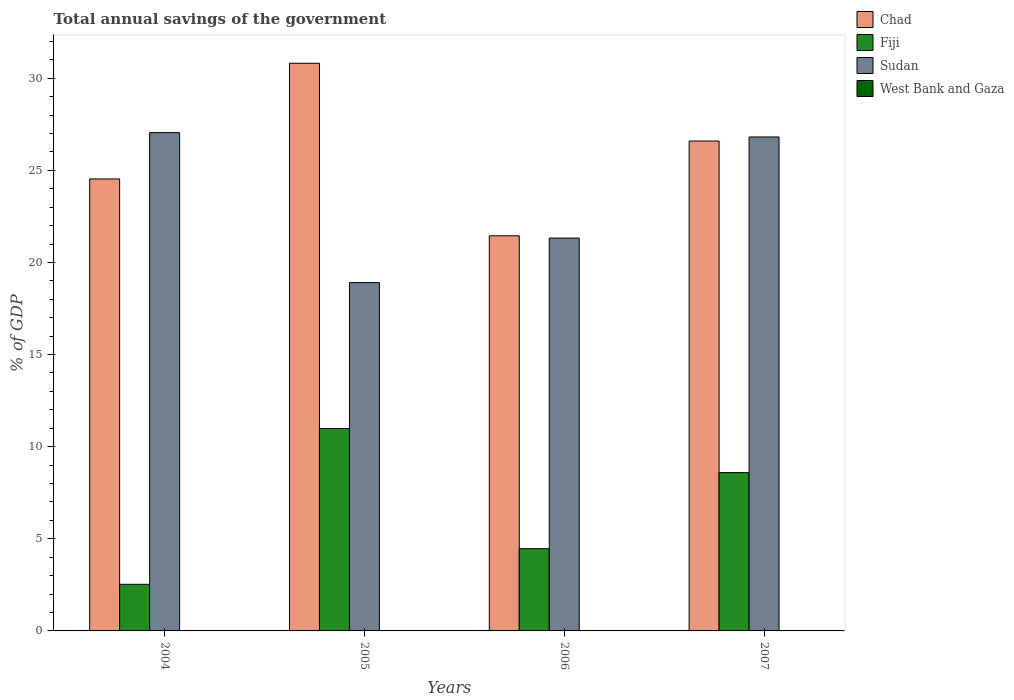How many different coloured bars are there?
Your answer should be very brief. 3. Are the number of bars per tick equal to the number of legend labels?
Your answer should be compact. No. Are the number of bars on each tick of the X-axis equal?
Offer a terse response. Yes. How many bars are there on the 1st tick from the left?
Your answer should be very brief. 3. How many bars are there on the 4th tick from the right?
Provide a short and direct response. 3. What is the total annual savings of the government in Fiji in 2006?
Provide a succinct answer. 4.47. Across all years, what is the maximum total annual savings of the government in Fiji?
Offer a very short reply. 10.99. What is the total total annual savings of the government in Fiji in the graph?
Provide a short and direct response. 26.58. What is the difference between the total annual savings of the government in Chad in 2004 and that in 2007?
Your response must be concise. -2.06. What is the difference between the total annual savings of the government in Fiji in 2007 and the total annual savings of the government in Chad in 2005?
Your answer should be very brief. -22.22. What is the average total annual savings of the government in Chad per year?
Provide a short and direct response. 25.85. In the year 2004, what is the difference between the total annual savings of the government in Fiji and total annual savings of the government in Chad?
Offer a very short reply. -22. In how many years, is the total annual savings of the government in Fiji greater than 20 %?
Offer a terse response. 0. What is the ratio of the total annual savings of the government in Sudan in 2004 to that in 2006?
Give a very brief answer. 1.27. What is the difference between the highest and the second highest total annual savings of the government in Sudan?
Give a very brief answer. 0.23. What is the difference between the highest and the lowest total annual savings of the government in Chad?
Keep it short and to the point. 9.36. Is the sum of the total annual savings of the government in Sudan in 2006 and 2007 greater than the maximum total annual savings of the government in Chad across all years?
Make the answer very short. Yes. Is it the case that in every year, the sum of the total annual savings of the government in Chad and total annual savings of the government in Sudan is greater than the sum of total annual savings of the government in West Bank and Gaza and total annual savings of the government in Fiji?
Offer a very short reply. No. Are the values on the major ticks of Y-axis written in scientific E-notation?
Provide a short and direct response. No. Does the graph contain any zero values?
Your response must be concise. Yes. Does the graph contain grids?
Keep it short and to the point. No. Where does the legend appear in the graph?
Make the answer very short. Top right. How many legend labels are there?
Offer a very short reply. 4. How are the legend labels stacked?
Provide a short and direct response. Vertical. What is the title of the graph?
Your response must be concise. Total annual savings of the government. Does "Jordan" appear as one of the legend labels in the graph?
Offer a terse response. No. What is the label or title of the Y-axis?
Provide a short and direct response. % of GDP. What is the % of GDP of Chad in 2004?
Offer a very short reply. 24.53. What is the % of GDP in Fiji in 2004?
Ensure brevity in your answer.  2.53. What is the % of GDP of Sudan in 2004?
Your answer should be very brief. 27.05. What is the % of GDP in West Bank and Gaza in 2004?
Ensure brevity in your answer.  0. What is the % of GDP in Chad in 2005?
Give a very brief answer. 30.81. What is the % of GDP of Fiji in 2005?
Provide a short and direct response. 10.99. What is the % of GDP of Sudan in 2005?
Your answer should be very brief. 18.9. What is the % of GDP in West Bank and Gaza in 2005?
Ensure brevity in your answer.  0. What is the % of GDP in Chad in 2006?
Provide a succinct answer. 21.45. What is the % of GDP of Fiji in 2006?
Provide a short and direct response. 4.47. What is the % of GDP in Sudan in 2006?
Ensure brevity in your answer.  21.32. What is the % of GDP of West Bank and Gaza in 2006?
Keep it short and to the point. 0. What is the % of GDP of Chad in 2007?
Make the answer very short. 26.59. What is the % of GDP of Fiji in 2007?
Your response must be concise. 8.59. What is the % of GDP in Sudan in 2007?
Give a very brief answer. 26.81. What is the % of GDP in West Bank and Gaza in 2007?
Give a very brief answer. 0. Across all years, what is the maximum % of GDP of Chad?
Offer a terse response. 30.81. Across all years, what is the maximum % of GDP of Fiji?
Ensure brevity in your answer.  10.99. Across all years, what is the maximum % of GDP in Sudan?
Give a very brief answer. 27.05. Across all years, what is the minimum % of GDP in Chad?
Offer a terse response. 21.45. Across all years, what is the minimum % of GDP in Fiji?
Provide a short and direct response. 2.53. Across all years, what is the minimum % of GDP in Sudan?
Your answer should be very brief. 18.9. What is the total % of GDP of Chad in the graph?
Offer a terse response. 103.38. What is the total % of GDP in Fiji in the graph?
Offer a terse response. 26.58. What is the total % of GDP of Sudan in the graph?
Provide a short and direct response. 94.09. What is the difference between the % of GDP of Chad in 2004 and that in 2005?
Make the answer very short. -6.28. What is the difference between the % of GDP in Fiji in 2004 and that in 2005?
Offer a very short reply. -8.46. What is the difference between the % of GDP of Sudan in 2004 and that in 2005?
Provide a short and direct response. 8.14. What is the difference between the % of GDP of Chad in 2004 and that in 2006?
Provide a short and direct response. 3.08. What is the difference between the % of GDP of Fiji in 2004 and that in 2006?
Make the answer very short. -1.94. What is the difference between the % of GDP in Sudan in 2004 and that in 2006?
Keep it short and to the point. 5.72. What is the difference between the % of GDP of Chad in 2004 and that in 2007?
Ensure brevity in your answer.  -2.06. What is the difference between the % of GDP in Fiji in 2004 and that in 2007?
Provide a short and direct response. -6.06. What is the difference between the % of GDP of Sudan in 2004 and that in 2007?
Provide a succinct answer. 0.23. What is the difference between the % of GDP in Chad in 2005 and that in 2006?
Provide a short and direct response. 9.36. What is the difference between the % of GDP of Fiji in 2005 and that in 2006?
Provide a short and direct response. 6.52. What is the difference between the % of GDP of Sudan in 2005 and that in 2006?
Keep it short and to the point. -2.42. What is the difference between the % of GDP in Chad in 2005 and that in 2007?
Provide a succinct answer. 4.22. What is the difference between the % of GDP in Fiji in 2005 and that in 2007?
Ensure brevity in your answer.  2.4. What is the difference between the % of GDP in Sudan in 2005 and that in 2007?
Your answer should be compact. -7.91. What is the difference between the % of GDP in Chad in 2006 and that in 2007?
Keep it short and to the point. -5.14. What is the difference between the % of GDP of Fiji in 2006 and that in 2007?
Offer a very short reply. -4.13. What is the difference between the % of GDP in Sudan in 2006 and that in 2007?
Ensure brevity in your answer.  -5.49. What is the difference between the % of GDP in Chad in 2004 and the % of GDP in Fiji in 2005?
Ensure brevity in your answer.  13.54. What is the difference between the % of GDP of Chad in 2004 and the % of GDP of Sudan in 2005?
Make the answer very short. 5.63. What is the difference between the % of GDP of Fiji in 2004 and the % of GDP of Sudan in 2005?
Provide a short and direct response. -16.37. What is the difference between the % of GDP of Chad in 2004 and the % of GDP of Fiji in 2006?
Keep it short and to the point. 20.07. What is the difference between the % of GDP in Chad in 2004 and the % of GDP in Sudan in 2006?
Ensure brevity in your answer.  3.21. What is the difference between the % of GDP in Fiji in 2004 and the % of GDP in Sudan in 2006?
Offer a terse response. -18.79. What is the difference between the % of GDP in Chad in 2004 and the % of GDP in Fiji in 2007?
Offer a very short reply. 15.94. What is the difference between the % of GDP of Chad in 2004 and the % of GDP of Sudan in 2007?
Provide a succinct answer. -2.28. What is the difference between the % of GDP of Fiji in 2004 and the % of GDP of Sudan in 2007?
Offer a very short reply. -24.28. What is the difference between the % of GDP of Chad in 2005 and the % of GDP of Fiji in 2006?
Keep it short and to the point. 26.35. What is the difference between the % of GDP of Chad in 2005 and the % of GDP of Sudan in 2006?
Provide a succinct answer. 9.49. What is the difference between the % of GDP of Fiji in 2005 and the % of GDP of Sudan in 2006?
Your answer should be compact. -10.34. What is the difference between the % of GDP in Chad in 2005 and the % of GDP in Fiji in 2007?
Your answer should be compact. 22.22. What is the difference between the % of GDP of Chad in 2005 and the % of GDP of Sudan in 2007?
Ensure brevity in your answer.  4. What is the difference between the % of GDP of Fiji in 2005 and the % of GDP of Sudan in 2007?
Provide a short and direct response. -15.82. What is the difference between the % of GDP of Chad in 2006 and the % of GDP of Fiji in 2007?
Your answer should be very brief. 12.86. What is the difference between the % of GDP of Chad in 2006 and the % of GDP of Sudan in 2007?
Offer a terse response. -5.36. What is the difference between the % of GDP in Fiji in 2006 and the % of GDP in Sudan in 2007?
Offer a terse response. -22.35. What is the average % of GDP of Chad per year?
Your answer should be very brief. 25.85. What is the average % of GDP in Fiji per year?
Provide a short and direct response. 6.64. What is the average % of GDP in Sudan per year?
Keep it short and to the point. 23.52. In the year 2004, what is the difference between the % of GDP of Chad and % of GDP of Fiji?
Keep it short and to the point. 22. In the year 2004, what is the difference between the % of GDP of Chad and % of GDP of Sudan?
Offer a terse response. -2.51. In the year 2004, what is the difference between the % of GDP in Fiji and % of GDP in Sudan?
Make the answer very short. -24.52. In the year 2005, what is the difference between the % of GDP in Chad and % of GDP in Fiji?
Ensure brevity in your answer.  19.82. In the year 2005, what is the difference between the % of GDP of Chad and % of GDP of Sudan?
Offer a very short reply. 11.91. In the year 2005, what is the difference between the % of GDP of Fiji and % of GDP of Sudan?
Provide a succinct answer. -7.92. In the year 2006, what is the difference between the % of GDP of Chad and % of GDP of Fiji?
Your answer should be very brief. 16.98. In the year 2006, what is the difference between the % of GDP of Chad and % of GDP of Sudan?
Provide a succinct answer. 0.12. In the year 2006, what is the difference between the % of GDP of Fiji and % of GDP of Sudan?
Keep it short and to the point. -16.86. In the year 2007, what is the difference between the % of GDP in Chad and % of GDP in Fiji?
Your response must be concise. 18. In the year 2007, what is the difference between the % of GDP in Chad and % of GDP in Sudan?
Offer a terse response. -0.22. In the year 2007, what is the difference between the % of GDP of Fiji and % of GDP of Sudan?
Keep it short and to the point. -18.22. What is the ratio of the % of GDP in Chad in 2004 to that in 2005?
Provide a succinct answer. 0.8. What is the ratio of the % of GDP in Fiji in 2004 to that in 2005?
Keep it short and to the point. 0.23. What is the ratio of the % of GDP of Sudan in 2004 to that in 2005?
Make the answer very short. 1.43. What is the ratio of the % of GDP of Chad in 2004 to that in 2006?
Provide a succinct answer. 1.14. What is the ratio of the % of GDP in Fiji in 2004 to that in 2006?
Ensure brevity in your answer.  0.57. What is the ratio of the % of GDP in Sudan in 2004 to that in 2006?
Your answer should be compact. 1.27. What is the ratio of the % of GDP of Chad in 2004 to that in 2007?
Ensure brevity in your answer.  0.92. What is the ratio of the % of GDP in Fiji in 2004 to that in 2007?
Give a very brief answer. 0.29. What is the ratio of the % of GDP in Sudan in 2004 to that in 2007?
Your response must be concise. 1.01. What is the ratio of the % of GDP in Chad in 2005 to that in 2006?
Your answer should be very brief. 1.44. What is the ratio of the % of GDP of Fiji in 2005 to that in 2006?
Offer a terse response. 2.46. What is the ratio of the % of GDP in Sudan in 2005 to that in 2006?
Your response must be concise. 0.89. What is the ratio of the % of GDP of Chad in 2005 to that in 2007?
Offer a terse response. 1.16. What is the ratio of the % of GDP of Fiji in 2005 to that in 2007?
Your response must be concise. 1.28. What is the ratio of the % of GDP of Sudan in 2005 to that in 2007?
Your answer should be compact. 0.71. What is the ratio of the % of GDP of Chad in 2006 to that in 2007?
Give a very brief answer. 0.81. What is the ratio of the % of GDP of Fiji in 2006 to that in 2007?
Your answer should be compact. 0.52. What is the ratio of the % of GDP of Sudan in 2006 to that in 2007?
Ensure brevity in your answer.  0.8. What is the difference between the highest and the second highest % of GDP of Chad?
Your answer should be very brief. 4.22. What is the difference between the highest and the second highest % of GDP in Fiji?
Offer a very short reply. 2.4. What is the difference between the highest and the second highest % of GDP of Sudan?
Your response must be concise. 0.23. What is the difference between the highest and the lowest % of GDP of Chad?
Your response must be concise. 9.36. What is the difference between the highest and the lowest % of GDP in Fiji?
Provide a short and direct response. 8.46. What is the difference between the highest and the lowest % of GDP of Sudan?
Your response must be concise. 8.14. 